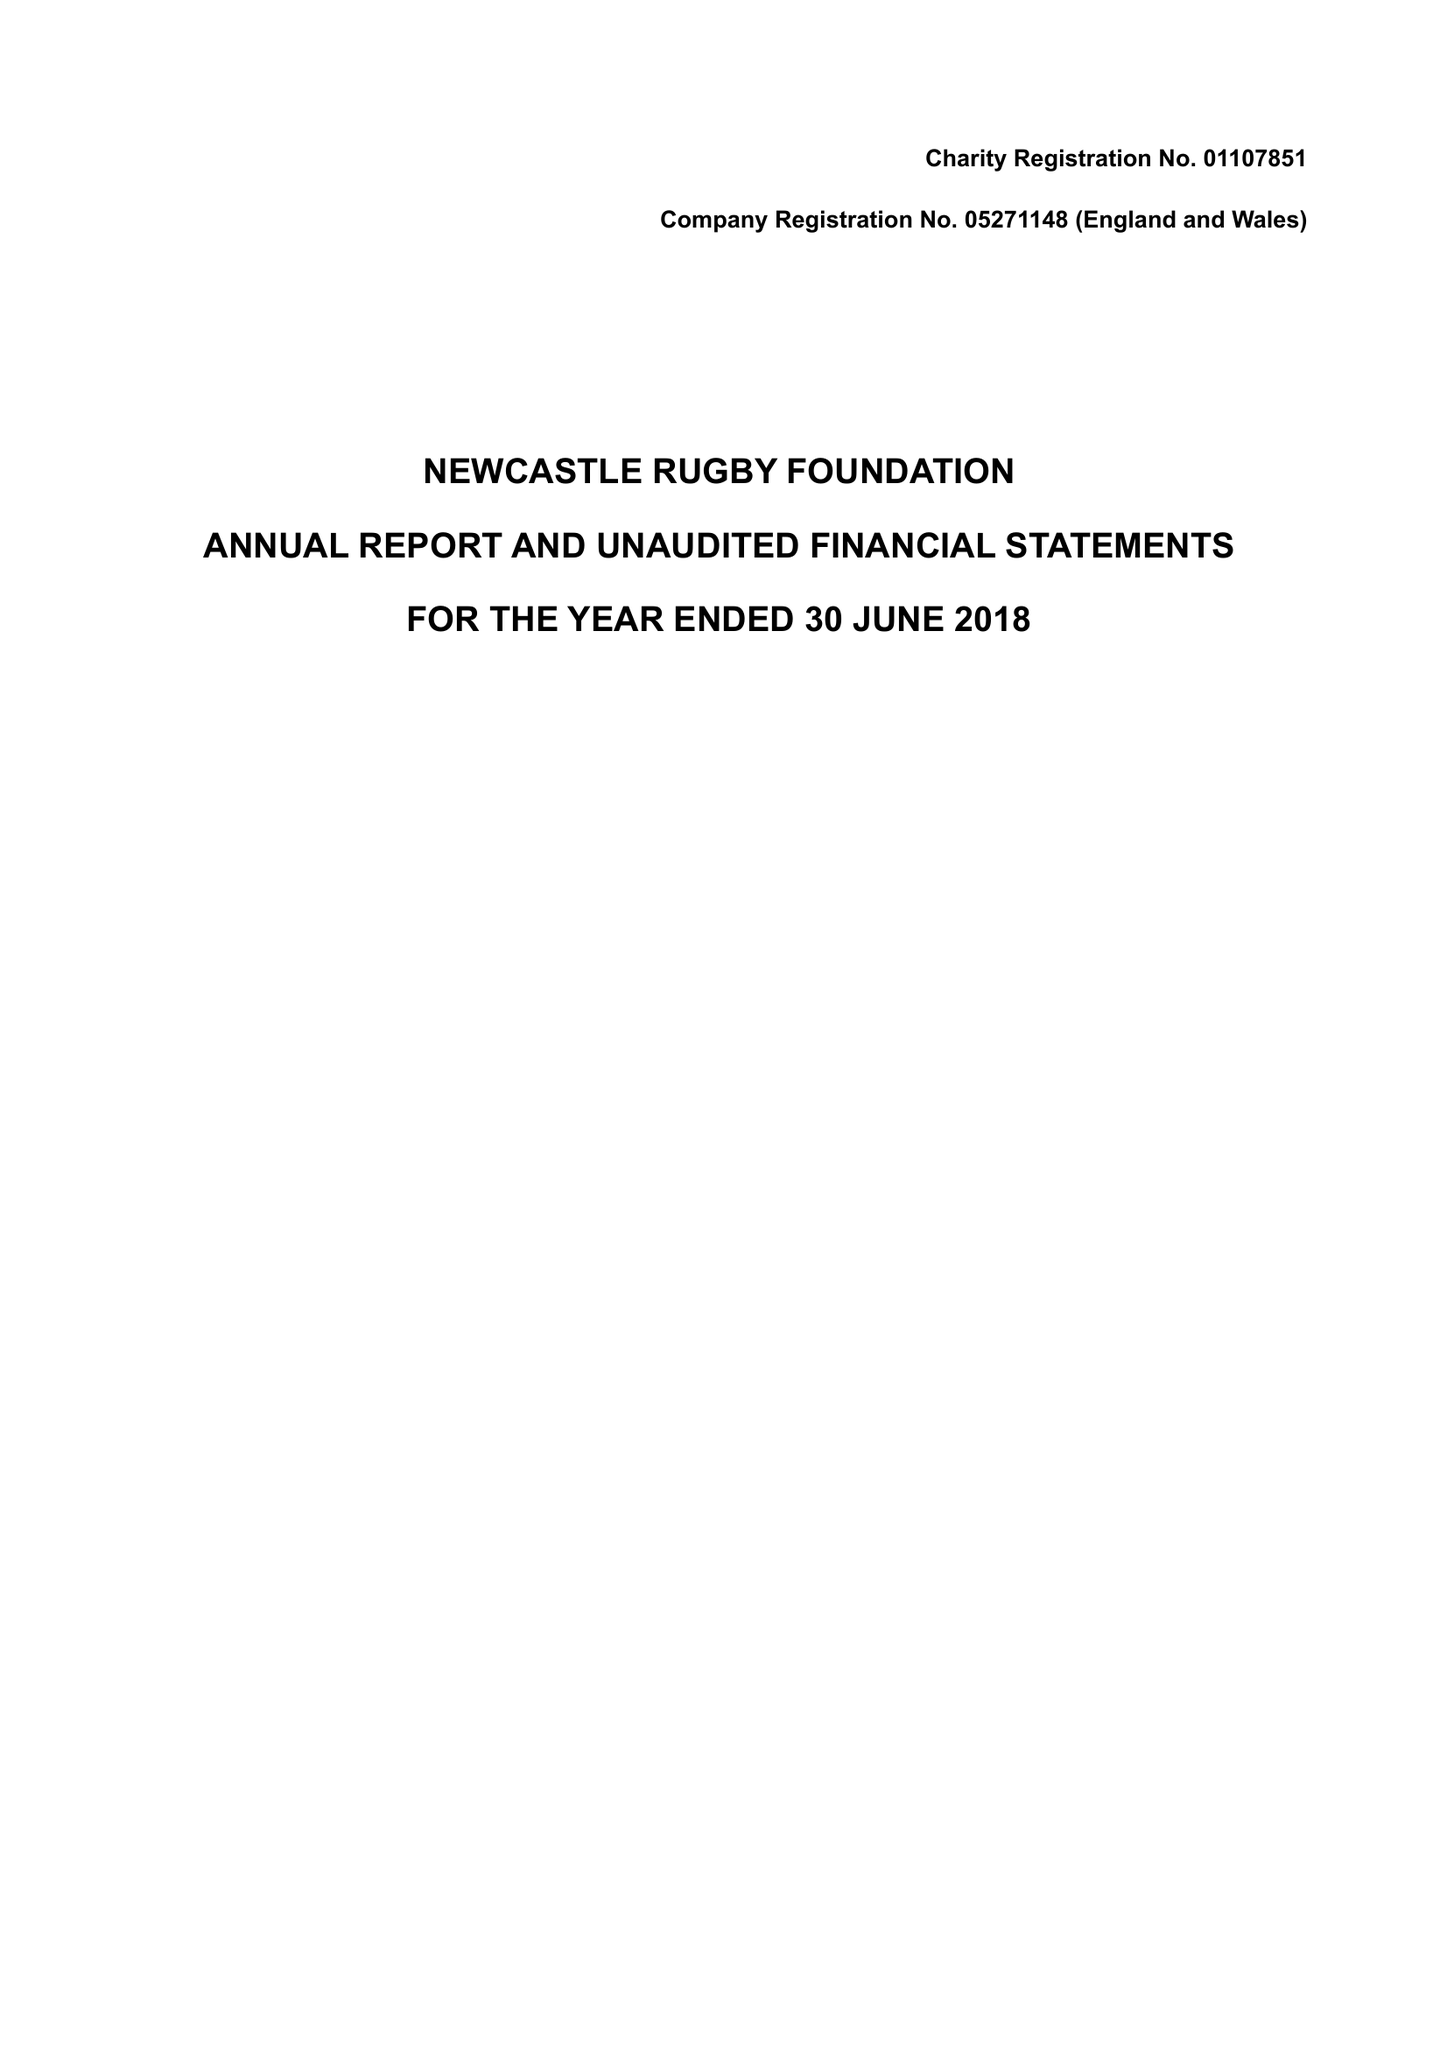What is the value for the charity_name?
Answer the question using a single word or phrase. Newcastle Rugby Foundation 